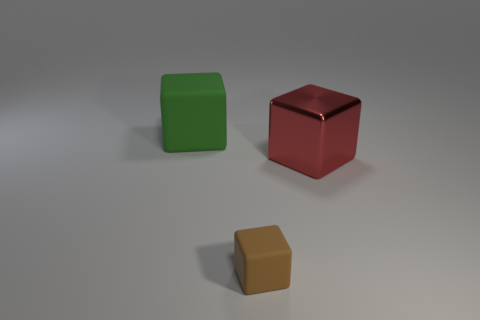What is the size of the brown thing that is made of the same material as the large green cube?
Your answer should be very brief. Small. Is there anything else that has the same material as the red thing?
Offer a very short reply. No. What is the size of the block that is to the left of the matte block that is in front of the big block that is in front of the green cube?
Ensure brevity in your answer.  Large. How many other things are there of the same color as the large matte object?
Offer a terse response. 0. There is a matte block that is in front of the green matte thing; is its size the same as the large green thing?
Keep it short and to the point. No. Does the object to the left of the brown matte thing have the same material as the small brown block in front of the big green rubber cube?
Keep it short and to the point. Yes. Are there any other metallic things of the same size as the green thing?
Your response must be concise. Yes. There is a object that is in front of the large cube that is in front of the large thing that is on the left side of the tiny object; what shape is it?
Keep it short and to the point. Cube. Is the number of tiny brown cubes in front of the small rubber cube greater than the number of brown rubber objects?
Ensure brevity in your answer.  No. Is there a large gray metallic thing that has the same shape as the big green thing?
Give a very brief answer. No. 